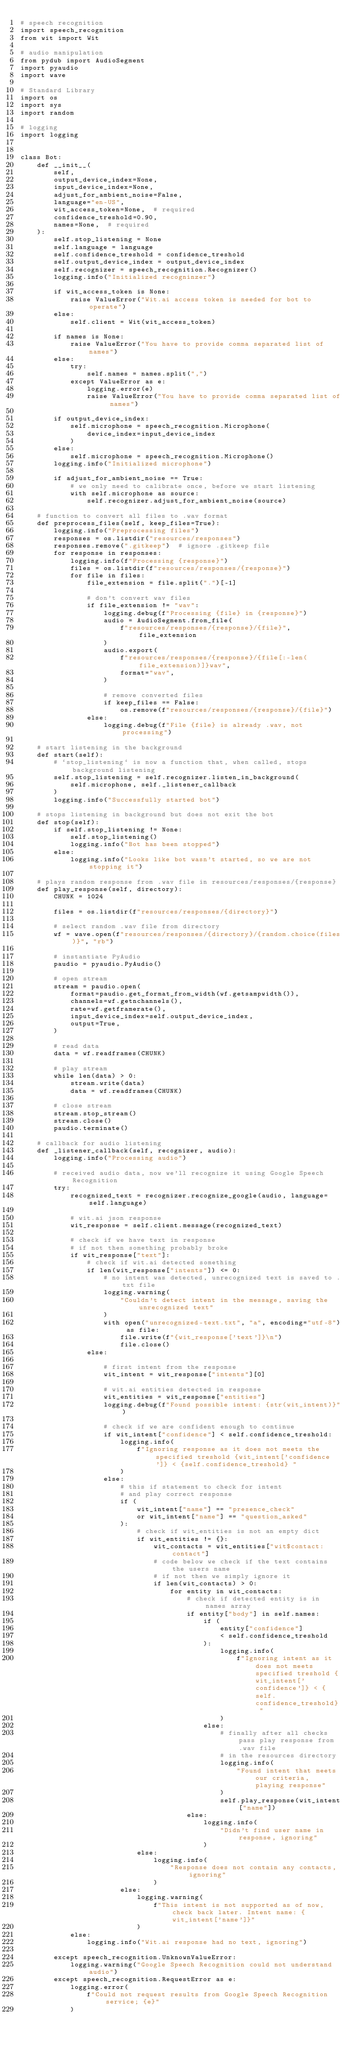Convert code to text. <code><loc_0><loc_0><loc_500><loc_500><_Python_># speech recognition
import speech_recognition
from wit import Wit

# audio manipulation
from pydub import AudioSegment
import pyaudio
import wave

# Standard Library
import os
import sys
import random

# logging
import logging


class Bot:
    def __init__(
        self,
        output_device_index=None,
        input_device_index=None,
        adjust_for_ambient_noise=False,
        language="en-US",
        wit_access_token=None,  # required
        confidence_treshold=0.90,
        names=None,  # required
    ):
        self.stop_listening = None
        self.language = language
        self.confidence_treshold = confidence_treshold
        self.output_device_index = output_device_index
        self.recognizer = speech_recognition.Recognizer()
        logging.info("Initialized recogninzer")

        if wit_access_token is None:
            raise ValueError("Wit.ai access token is needed for bot to operate")
        else:
            self.client = Wit(wit_access_token)

        if names is None:
            raise ValueError("You have to provide comma separated list of names")
        else:
            try:
                self.names = names.split(",")
            except ValueError as e:
                logging.error(e)
                raise ValueError("You have to provide comma separated list of names")

        if output_device_index:
            self.microphone = speech_recognition.Microphone(
                device_index=input_device_index
            )
        else:
            self.microphone = speech_recognition.Microphone()
        logging.info("Initialized microphone")

        if adjust_for_ambient_noise == True:
            # we only need to calibrate once, before we start listening
            with self.microphone as source:
                self.recognizer.adjust_for_ambient_noise(source)

    # function to convert all files to .wav format
    def preprocess_files(self, keep_files=True):
        logging.info("Preprocessing files")
        responses = os.listdir("resources/responses")
        responses.remove(".gitkeep")  # ignore .gitkeep file
        for response in responses:
            logging.info(f"Processing {response}")
            files = os.listdir(f"resources/responses/{response}")
            for file in files:
                file_extension = file.split(".")[-1]

                # don't convert wav files
                if file_extension != "wav":
                    logging.debug(f"Processing {file} in {response}")
                    audio = AudioSegment.from_file(
                        f"resources/responses/{response}/{file}", file_extension
                    )
                    audio.export(
                        f"resources/responses/{response}/{file[:-len(file_extension)]}wav",
                        format="wav",
                    )

                    # remove converted files
                    if keep_files == False:
                        os.remove(f"resources/responses/{response}/{file}")
                else:
                    logging.debug(f"File {file} is already .wav, not processing")

    # start listening in the background
    def start(self):
        # `stop_listening` is now a function that, when called, stops background listening
        self.stop_listening = self.recognizer.listen_in_background(
            self.microphone, self._listener_callback
        )
        logging.info("Successfully started bot")

    # stops listening in background but does not exit the bot
    def stop(self):
        if self.stop_listening != None:
            self.stop_listening()
            logging.info("Bot has been stopped")
        else:
            logging.info("Looks like bot wasn't started, so we are not stopping it")

    # plays random response from .wav file in resources/responses/{response}
    def play_response(self, directory):
        CHUNK = 1024

        files = os.listdir(f"resources/responses/{directory}")

        # select random .wav file from directory
        wf = wave.open(f"resources/responses/{directory}/{random.choice(files)}", "rb")

        # instantiate PyAudio
        paudio = pyaudio.PyAudio()

        # open stream
        stream = paudio.open(
            format=paudio.get_format_from_width(wf.getsampwidth()),
            channels=wf.getnchannels(),
            rate=wf.getframerate(),
            input_device_index=self.output_device_index,
            output=True,
        )

        # read data
        data = wf.readframes(CHUNK)

        # play stream
        while len(data) > 0:
            stream.write(data)
            data = wf.readframes(CHUNK)

        # close stream
        stream.stop_stream()
        stream.close()
        paudio.terminate()

    # callback for audio listening
    def _listener_callback(self, recognizer, audio):
        logging.info("Processing audio")

        # received audio data, now we'll recognize it using Google Speech Recognition
        try:
            recognized_text = recognizer.recognize_google(audio, language=self.language)

            # wit.ai json response
            wit_response = self.client.message(recognized_text)

            # check if we have text in response
            # if not then something probably broke
            if wit_response["text"]:
                # check if wit.ai detected something
                if len(wit_response["intents"]) <= 0:
                    # no intent was detected, unrecognized text is saved to .txt file
                    logging.warning(
                        "Couldn't detect intent in the message, saving the unrecognized text"
                    )
                    with open("unrecognized-text.txt", "a", encoding="utf-8") as file:
                        file.write(f"{wit_response['text']}\n")
                        file.close()
                else:

                    # first intent from the response
                    wit_intent = wit_response["intents"][0]

                    # wit.ai entities detected in response
                    wit_entities = wit_response["entities"]
                    logging.debug(f"Found possible intent: {str(wit_intent)}")

                    # check if we are confident enough to continue
                    if wit_intent["confidence"] < self.confidence_treshold:
                        logging.info(
                            f"Ignoring response as it does not meets the specified treshold {wit_intent['confidence']} < {self.confidence_treshold} "
                        )
                    else:
                        # this if statement to check for intent
                        # and play correct response
                        if (
                            wit_intent["name"] == "presence_check"
                            or wit_intent["name"] == "question_asked"
                        ):
                            # check if wit_entities is not an empty dict
                            if wit_entities != {}:
                                wit_contacts = wit_entities["wit$contact:contact"]
                                # code below we check if the text contains the users name
                                # if not then we simply ignore it
                                if len(wit_contacts) > 0:
                                    for entity in wit_contacts:
                                        # check if detected entity is in names array
                                        if entity["body"] in self.names:
                                            if (
                                                entity["confidence"]
                                                < self.confidence_treshold
                                            ):
                                                logging.info(
                                                    f"Ignoring intent as it does not meets specified treshold {wit_intent['confidence']} < {self.confidence_treshold} "
                                                )
                                            else:
                                                # finally after all checks pass play response from .wav file
                                                # in the resources directory
                                                logging.info(
                                                    "Found intent that meets our criteria, playing response"
                                                )
                                                self.play_response(wit_intent["name"])
                                        else:
                                            logging.info(
                                                "Didn't find user name in response, ignoring"
                                            )
                            else:
                                logging.info(
                                    "Response does not contain any contacts, ignoring"
                                )
                        else:
                            logging.warning(
                                f"This intent is not supported as of now, check back later. Intent name: {wit_intent['name']}"
                            )
            else:
                logging.info("Wit.ai response had no text, ignoring")

        except speech_recognition.UnknownValueError:
            logging.warning("Google Speech Recognition could not understand audio")
        except speech_recognition.RequestError as e:
            logging.error(
                f"Could not request results from Google Speech Recognition service; {e}"
            )
</code> 